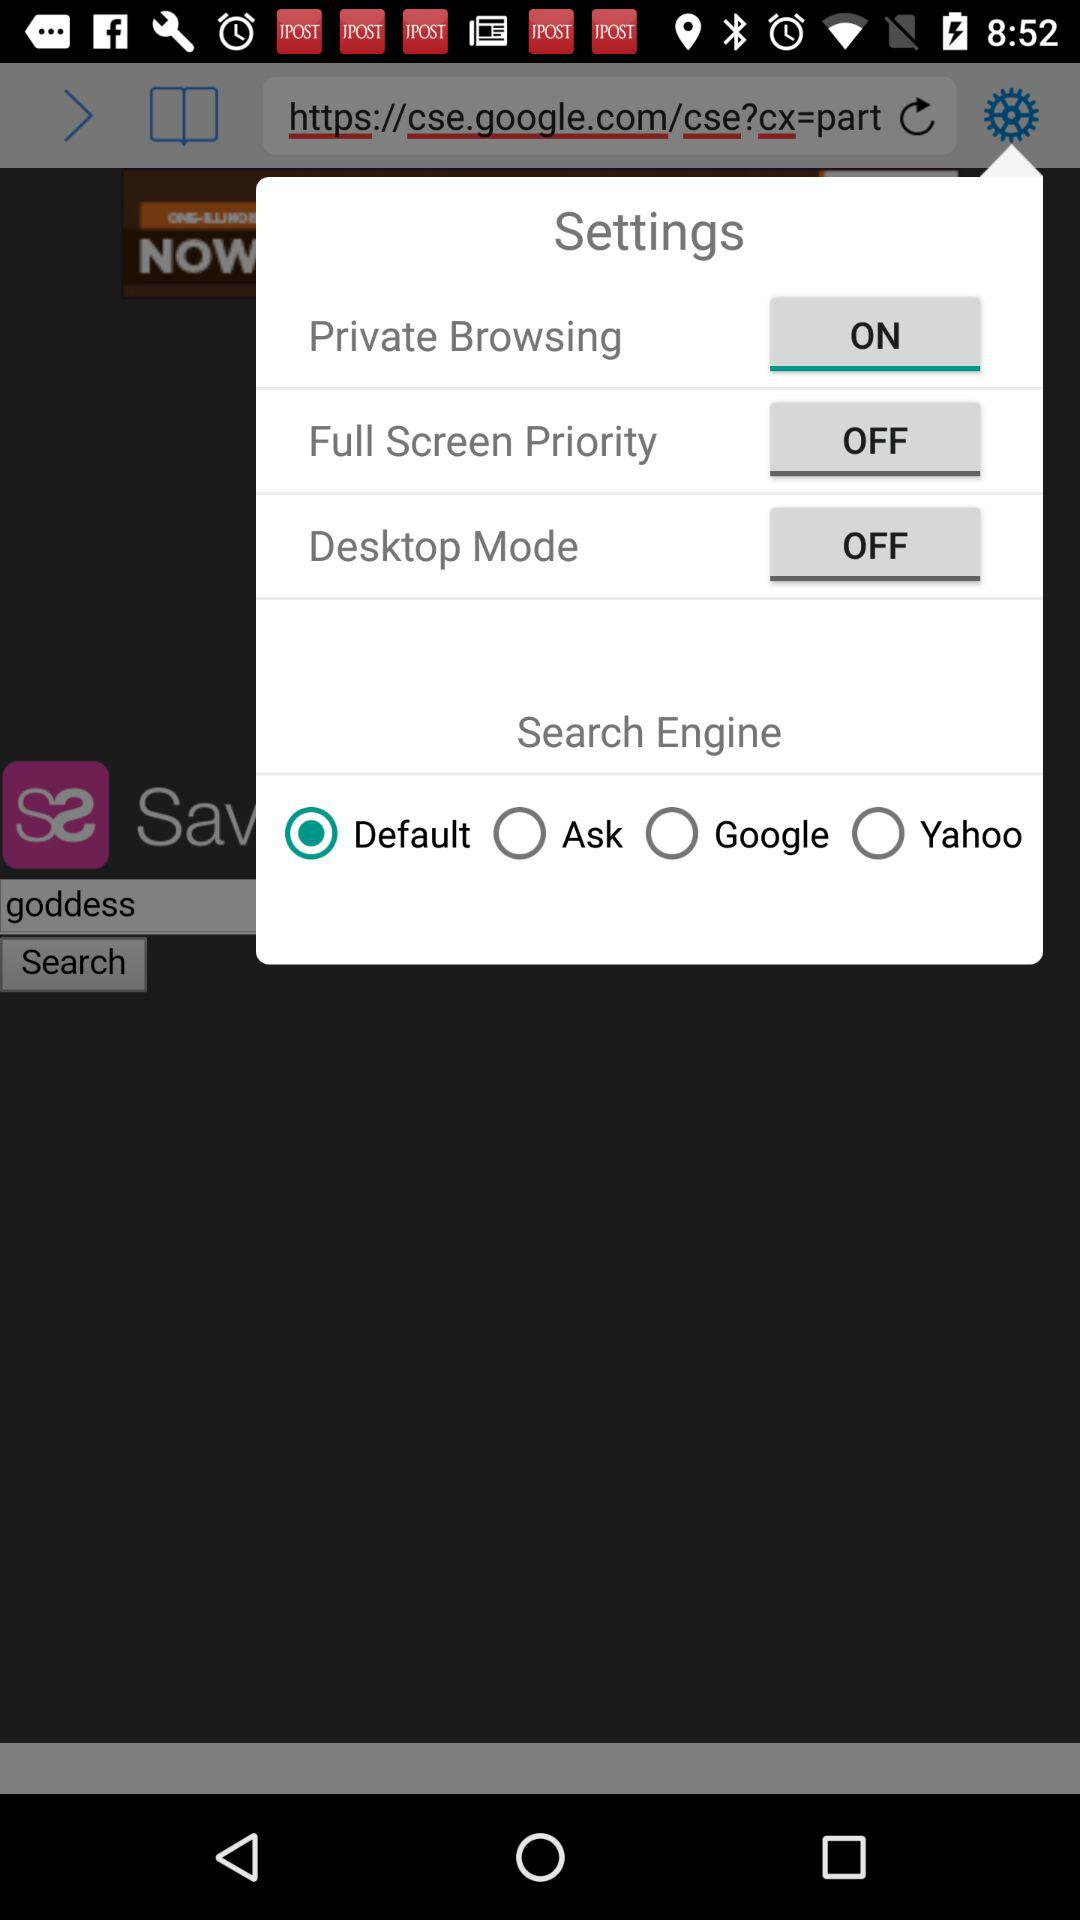What is the status of "Private Browsing"? "Private Browsing" is turned on. 